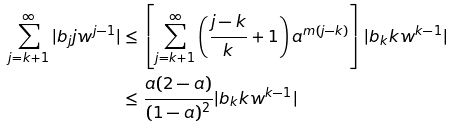Convert formula to latex. <formula><loc_0><loc_0><loc_500><loc_500>\sum _ { j = k + 1 } ^ { \infty } | b _ { j } j w ^ { j - 1 } | & \leq \left [ \sum _ { j = k + 1 } ^ { \infty } \left ( \frac { j - k } { k } + 1 \right ) a ^ { m ( j - k ) } \right ] | b _ { k } k w ^ { k - 1 } | \\ & \leq \frac { a ( 2 - a ) } { ( 1 - a ) ^ { 2 } } | b _ { k } k w ^ { k - 1 } |</formula> 